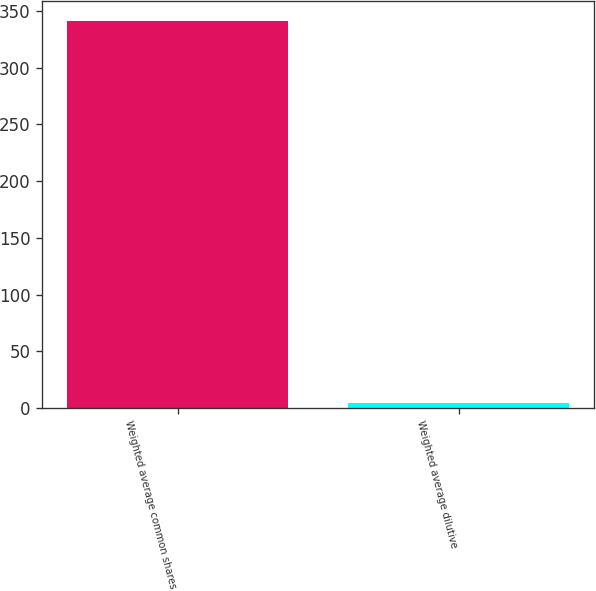Convert chart. <chart><loc_0><loc_0><loc_500><loc_500><bar_chart><fcel>Weighted average common shares<fcel>Weighted average dilutive<nl><fcel>341.33<fcel>4.4<nl></chart> 